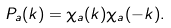<formula> <loc_0><loc_0><loc_500><loc_500>P _ { a } ( { k } ) = \chi _ { a } ( { k } ) \chi _ { a } ( { - k } ) .</formula> 